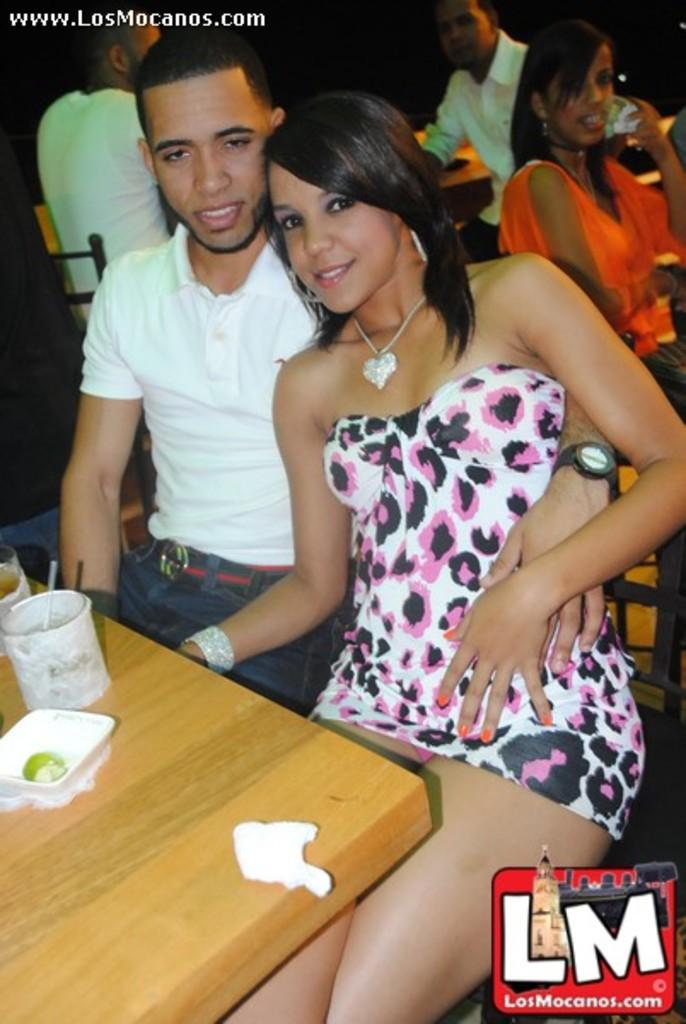What are the people in the image doing? There is a group of people sitting on a chair. What objects can be seen on the table in the image? There are glasses, a bowl, and tissue on a table. How loud is the crowd in the image? There is no crowd present in the image, only a group of people sitting on a chair. What unit of measurement is used to determine the noise level in the image? There is no mention of noise or measurement in the image, as it only features a group of people sitting on a chair and objects on a table. 